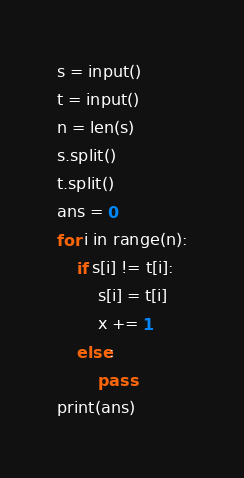<code> <loc_0><loc_0><loc_500><loc_500><_Python_>s = input()
t = input()
n = len(s)
s.split()
t.split()
ans = 0
for i in range(n):
    if s[i] != t[i]:
        s[i] = t[i]
        x += 1
    else:
        pass
print(ans)</code> 